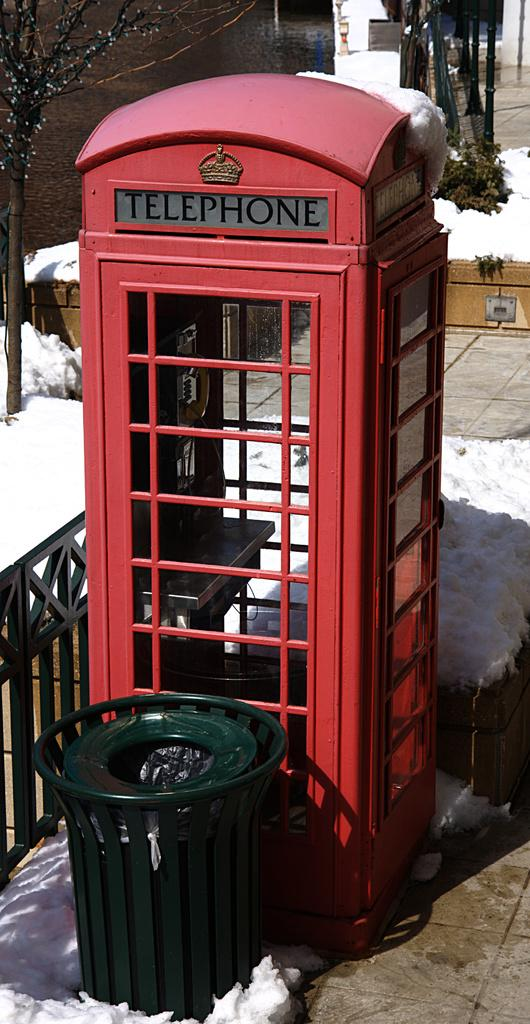Provide a one-sentence caption for the provided image. A red booth used for making telephone calls is surrounded by snow. 